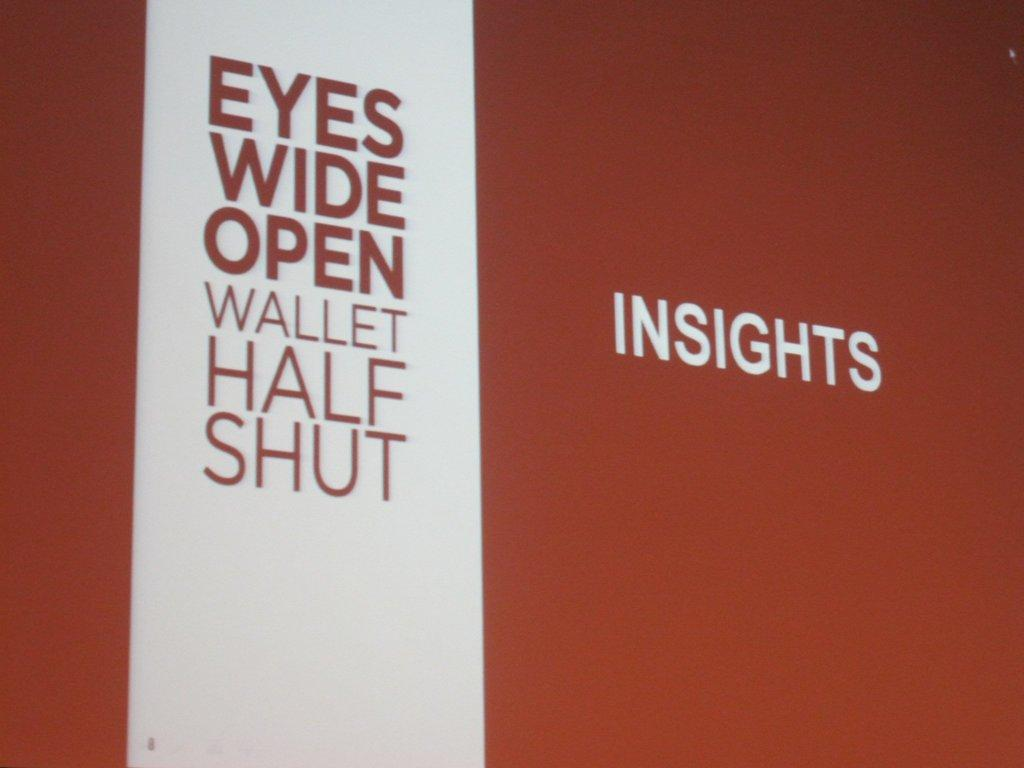<image>
Offer a succinct explanation of the picture presented. A red and white sign says Eyes Wide Open Wallet Half Shut. 